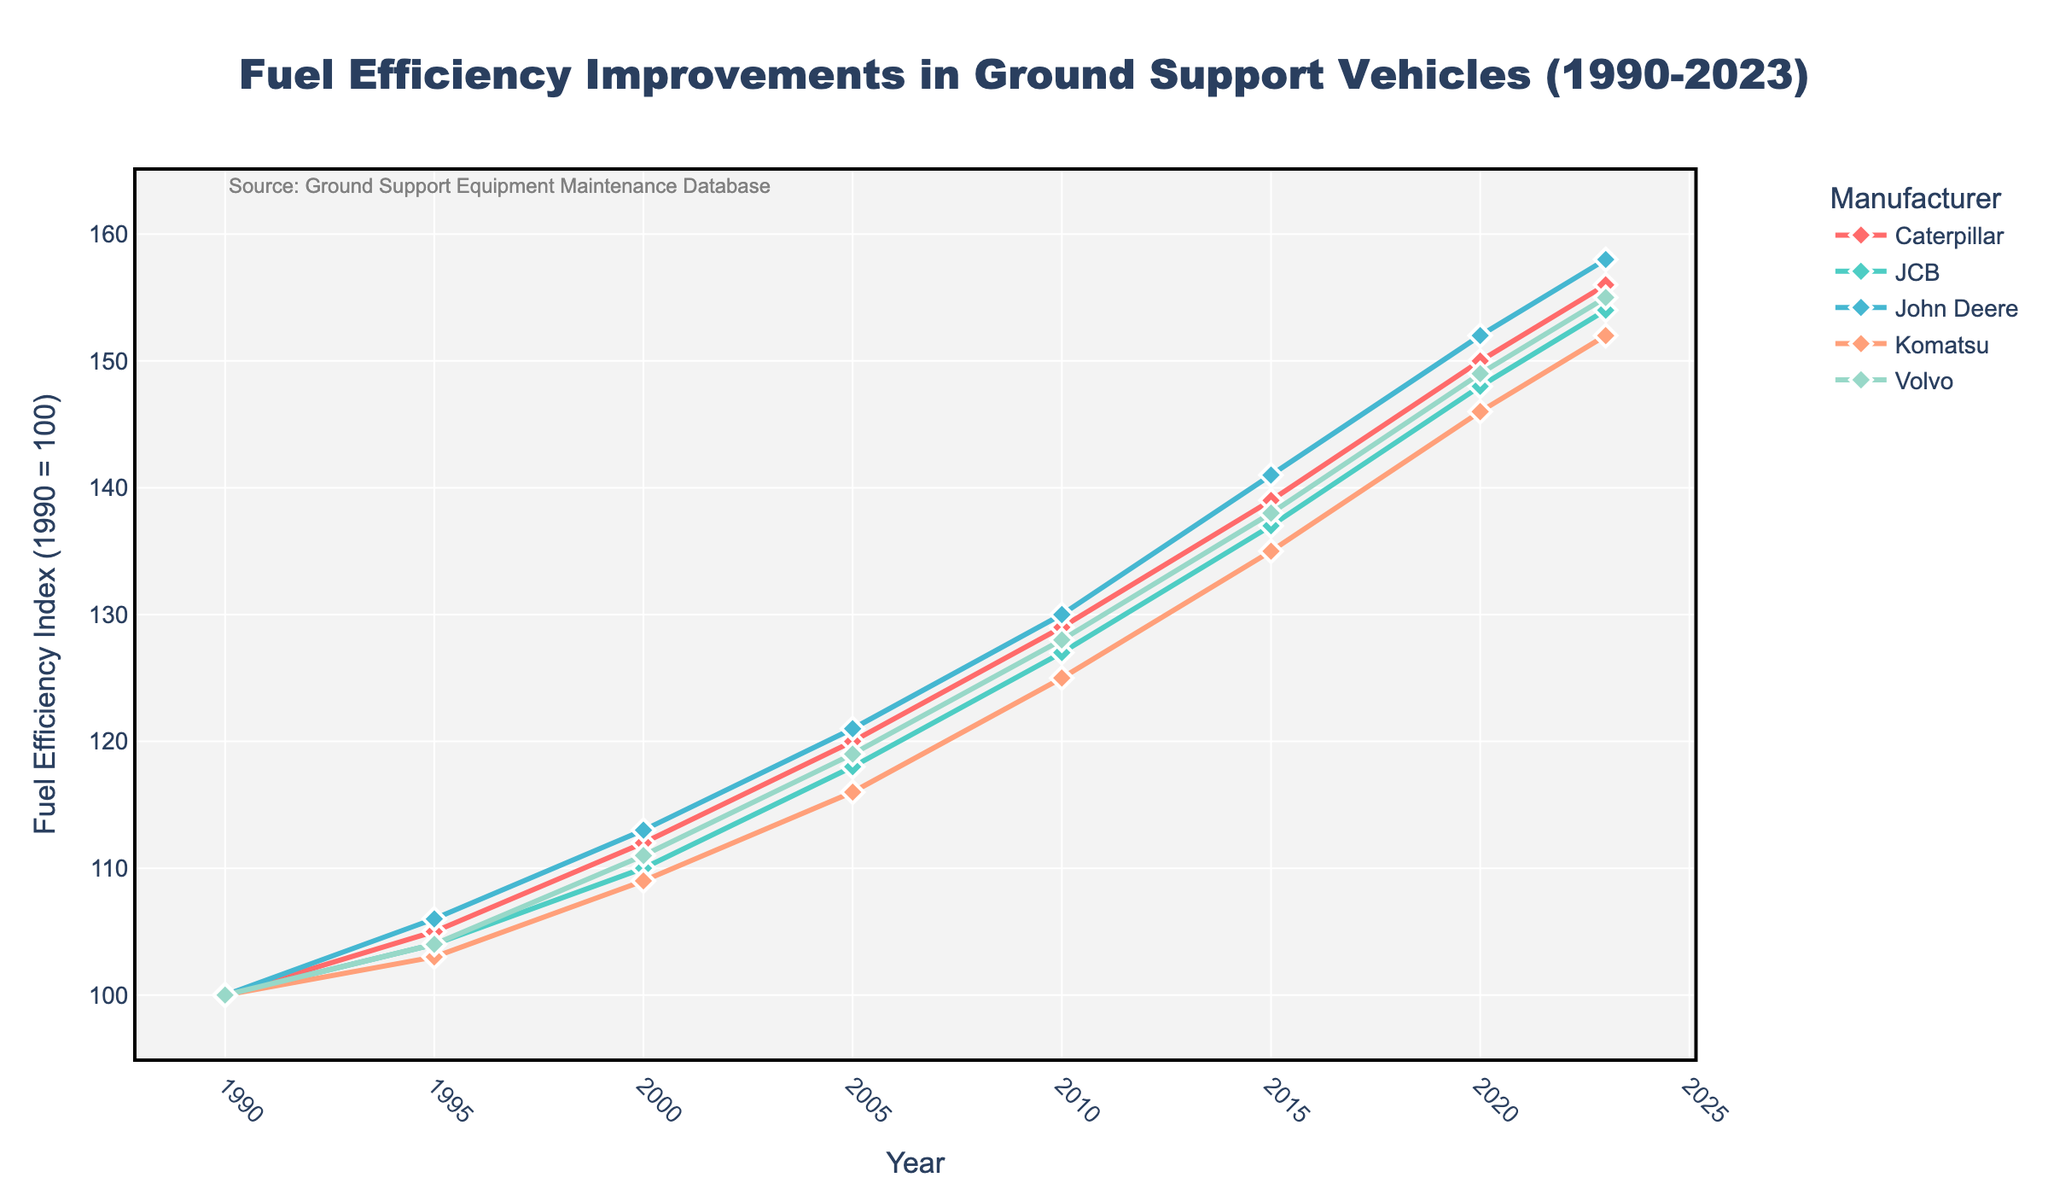How has the fuel efficiency of Volvo changed from 1990 to 2023? In 1990, the fuel efficiency index for Volvo was 100. By 2023, it had increased to 155. The change is 155 - 100 = 55.
Answer: 55 Which manufacturer had the highest fuel efficiency in 2020? In the figure, the data for 2020 shows John Deere at the highest value of 152 among all manufacturers.
Answer: John Deere Between which two consecutive years did Caterpillar see the highest increase in fuel efficiency? Checking Caterpillar's values for all years: the differences are 5 (1995), 7 (2000), 8 (2005), 9 (2010), 10 (2015), 11 (2020), and 6 (2023). The highest increase of 11 occurred between 2015 and 2020.
Answer: 2015 and 2020 What is the average fuel efficiency improvement across all manufacturers in 2000? Adding the values for 2000: 112 (Caterpillar) + 110 (JCB) + 113 (John Deere) + 109 (Komatsu) + 111 (Volvo) = 555. The average is 555 / 5 = 111.
Answer: 111 Is the fuel efficiency of Komatsu in 2005 greater than that of JCB in 2023? The value for Komatsu in 2005 is 116, and the value for JCB in 2023 is 154. 116 is less than 154.
Answer: No Which manufacturer has consistently shown the lowest fuel efficiency improvement across the years? By comparing the data visually for all years, JCB consistently shows lower values compared to the other manufacturers.
Answer: JCB What is the difference in fuel efficiency between John Deere and Caterpillar in 2015? John Deere had a value of 141 in 2015 and Caterpillar had 139. The difference is 141 - 139 = 2.
Answer: 2 How many years did Caterpillar's fuel efficiency remain under 130? Checking the Caterpillar data, the years where the efficiency is under 130: 1990, 1995, 2000, 2005, and 2010, which is 5 years.
Answer: 5 By how much did JCB's fuel efficiency improve from 2000 to 2023? JCB's values are 110 in 2000 and 154 in 2023. The improvement is 154 - 110 = 44.
Answer: 44 